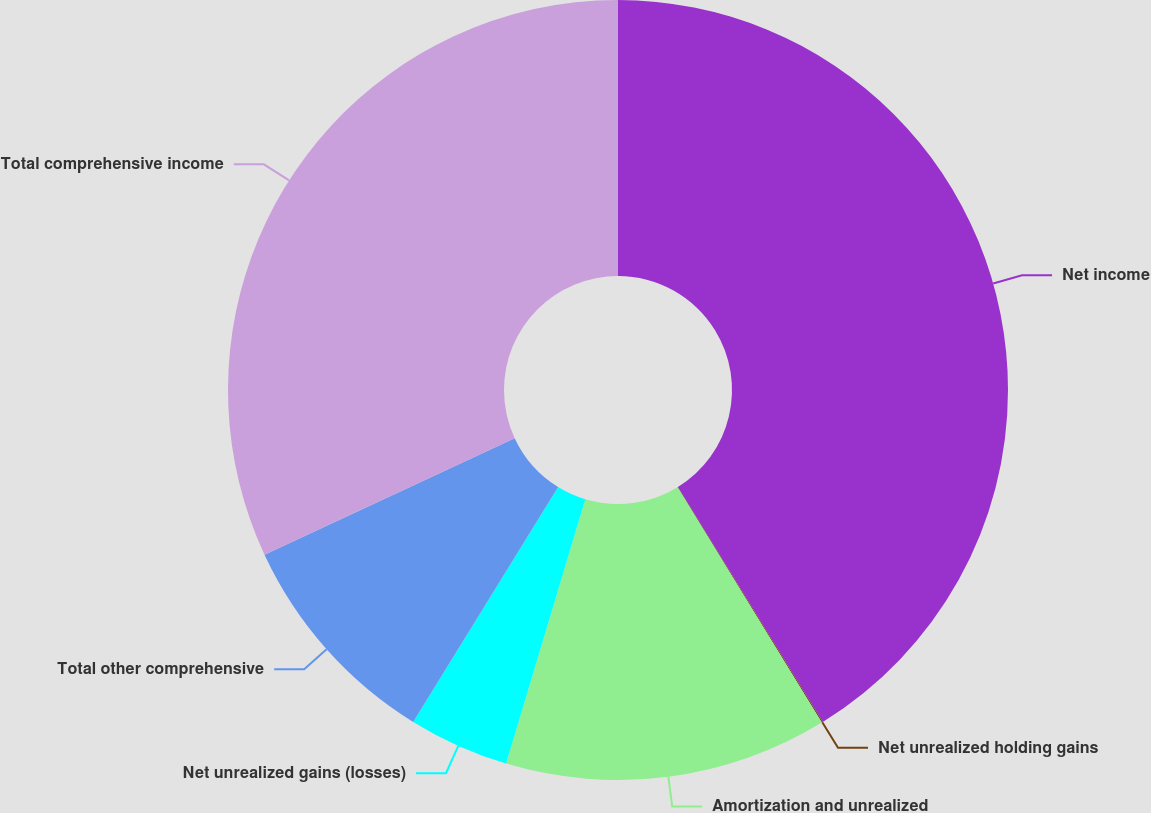Convert chart to OTSL. <chart><loc_0><loc_0><loc_500><loc_500><pie_chart><fcel>Net income<fcel>Net unrealized holding gains<fcel>Amortization and unrealized<fcel>Net unrealized gains (losses)<fcel>Total other comprehensive<fcel>Total comprehensive income<nl><fcel>41.2%<fcel>0.05%<fcel>13.38%<fcel>4.17%<fcel>9.26%<fcel>31.94%<nl></chart> 